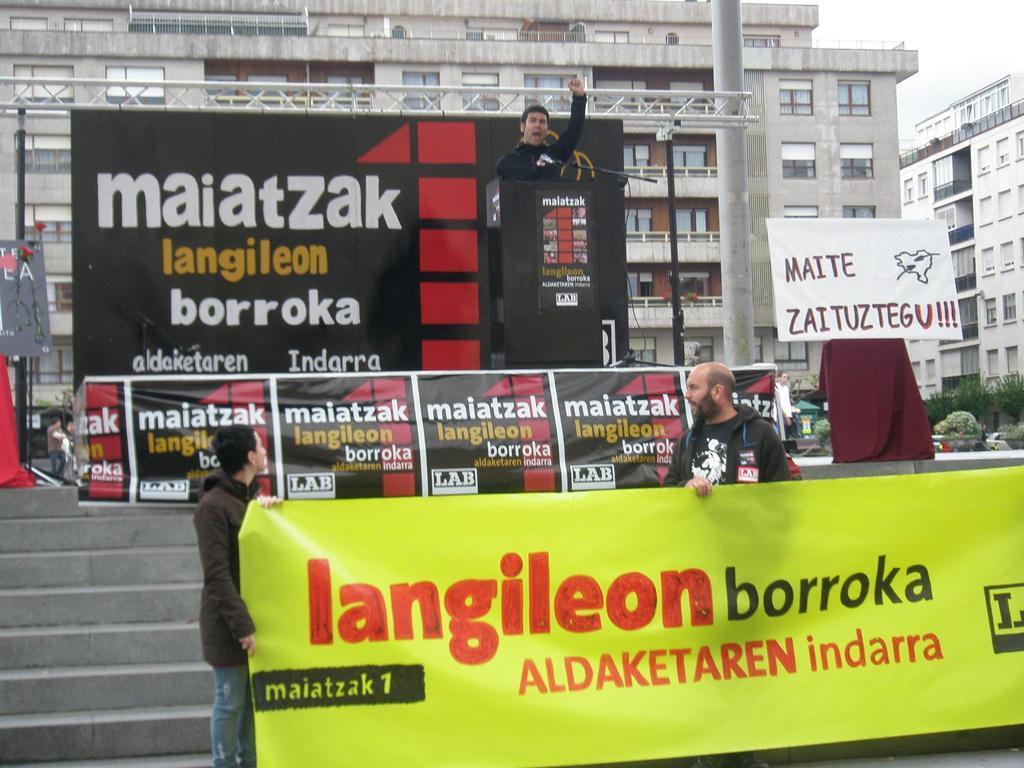Please provide a concise description of this image. In this picture we can see two men are standing and holding a banner in the front, there is a hoarding in the middle, we can see a man is standing in front of a podium, on the right side there is a board, in the background we can see buildings, on the left side we can see a pole, there are some plants on the right side, we can see some text on this hoarding, there is the sky at the right top of the picture. 